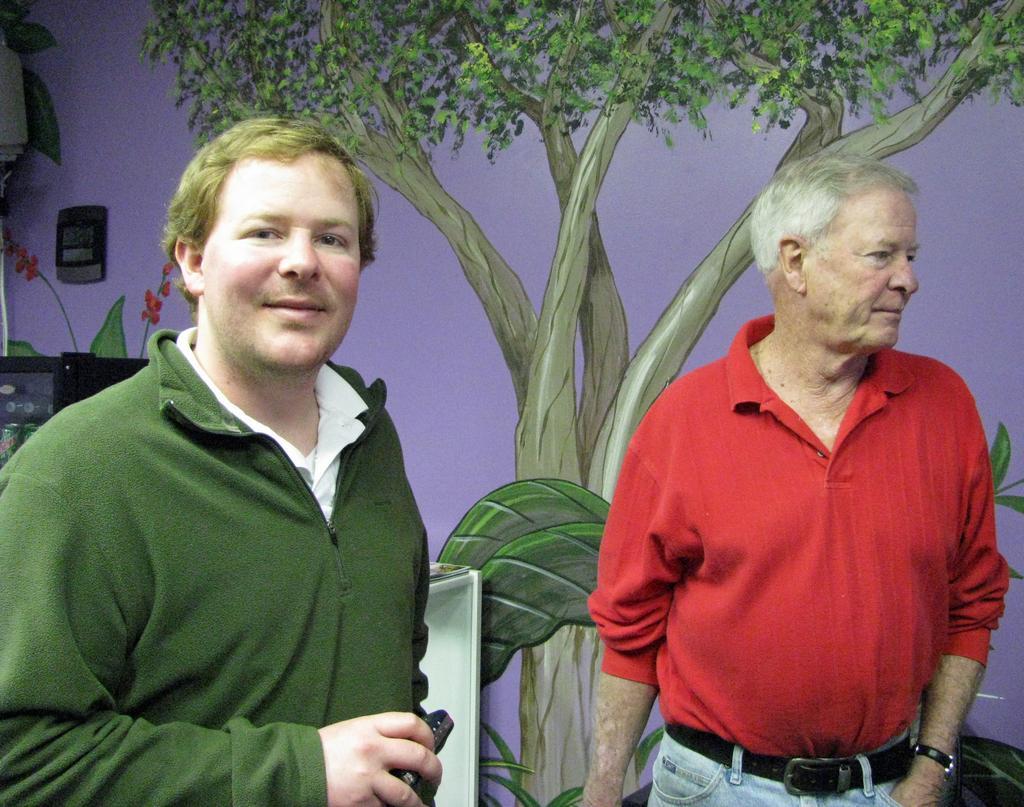Describe this image in one or two sentences. There is a wall and a painting of a tree is done on the wall. There are two people standing in front of the wall and one person is looking towards the camera, there is a refrigerator behind the man. 